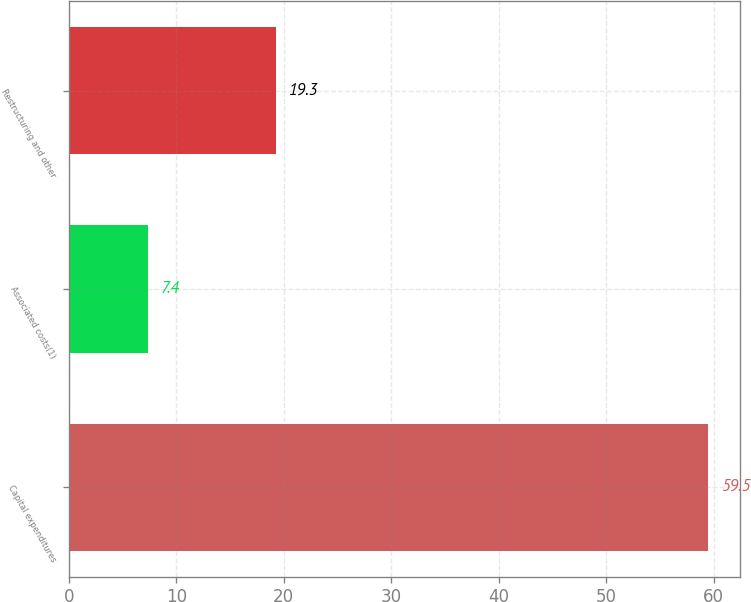<chart> <loc_0><loc_0><loc_500><loc_500><bar_chart><fcel>Capital expenditures<fcel>Associated costs(1)<fcel>Restructuring and other<nl><fcel>59.5<fcel>7.4<fcel>19.3<nl></chart> 